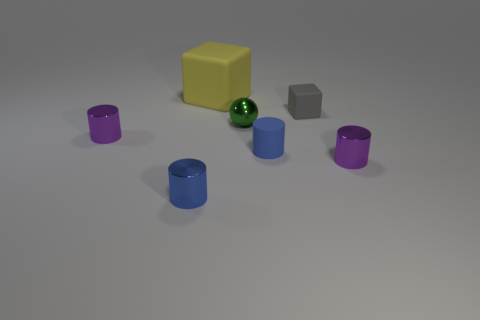There is a purple metal object that is on the right side of the sphere; is it the same size as the tiny blue rubber cylinder?
Your response must be concise. Yes. Is the number of tiny green cubes greater than the number of green shiny objects?
Give a very brief answer. No. How many other things are the same material as the tiny gray object?
Ensure brevity in your answer.  2. What is the shape of the metallic object that is to the right of the small metallic object behind the tiny purple metal cylinder that is to the left of the small matte block?
Keep it short and to the point. Cylinder. Are there fewer tiny matte objects in front of the yellow rubber block than cylinders that are right of the small gray matte thing?
Make the answer very short. No. Are there any small cylinders of the same color as the small ball?
Offer a very short reply. No. Is the large yellow block made of the same material as the gray cube behind the green object?
Your answer should be very brief. Yes. There is a tiny rubber object that is in front of the tiny green thing; are there any tiny rubber cylinders that are in front of it?
Your response must be concise. No. There is a matte object that is both to the left of the tiny gray matte thing and in front of the big yellow block; what is its color?
Keep it short and to the point. Blue. What size is the green ball?
Offer a very short reply. Small. 